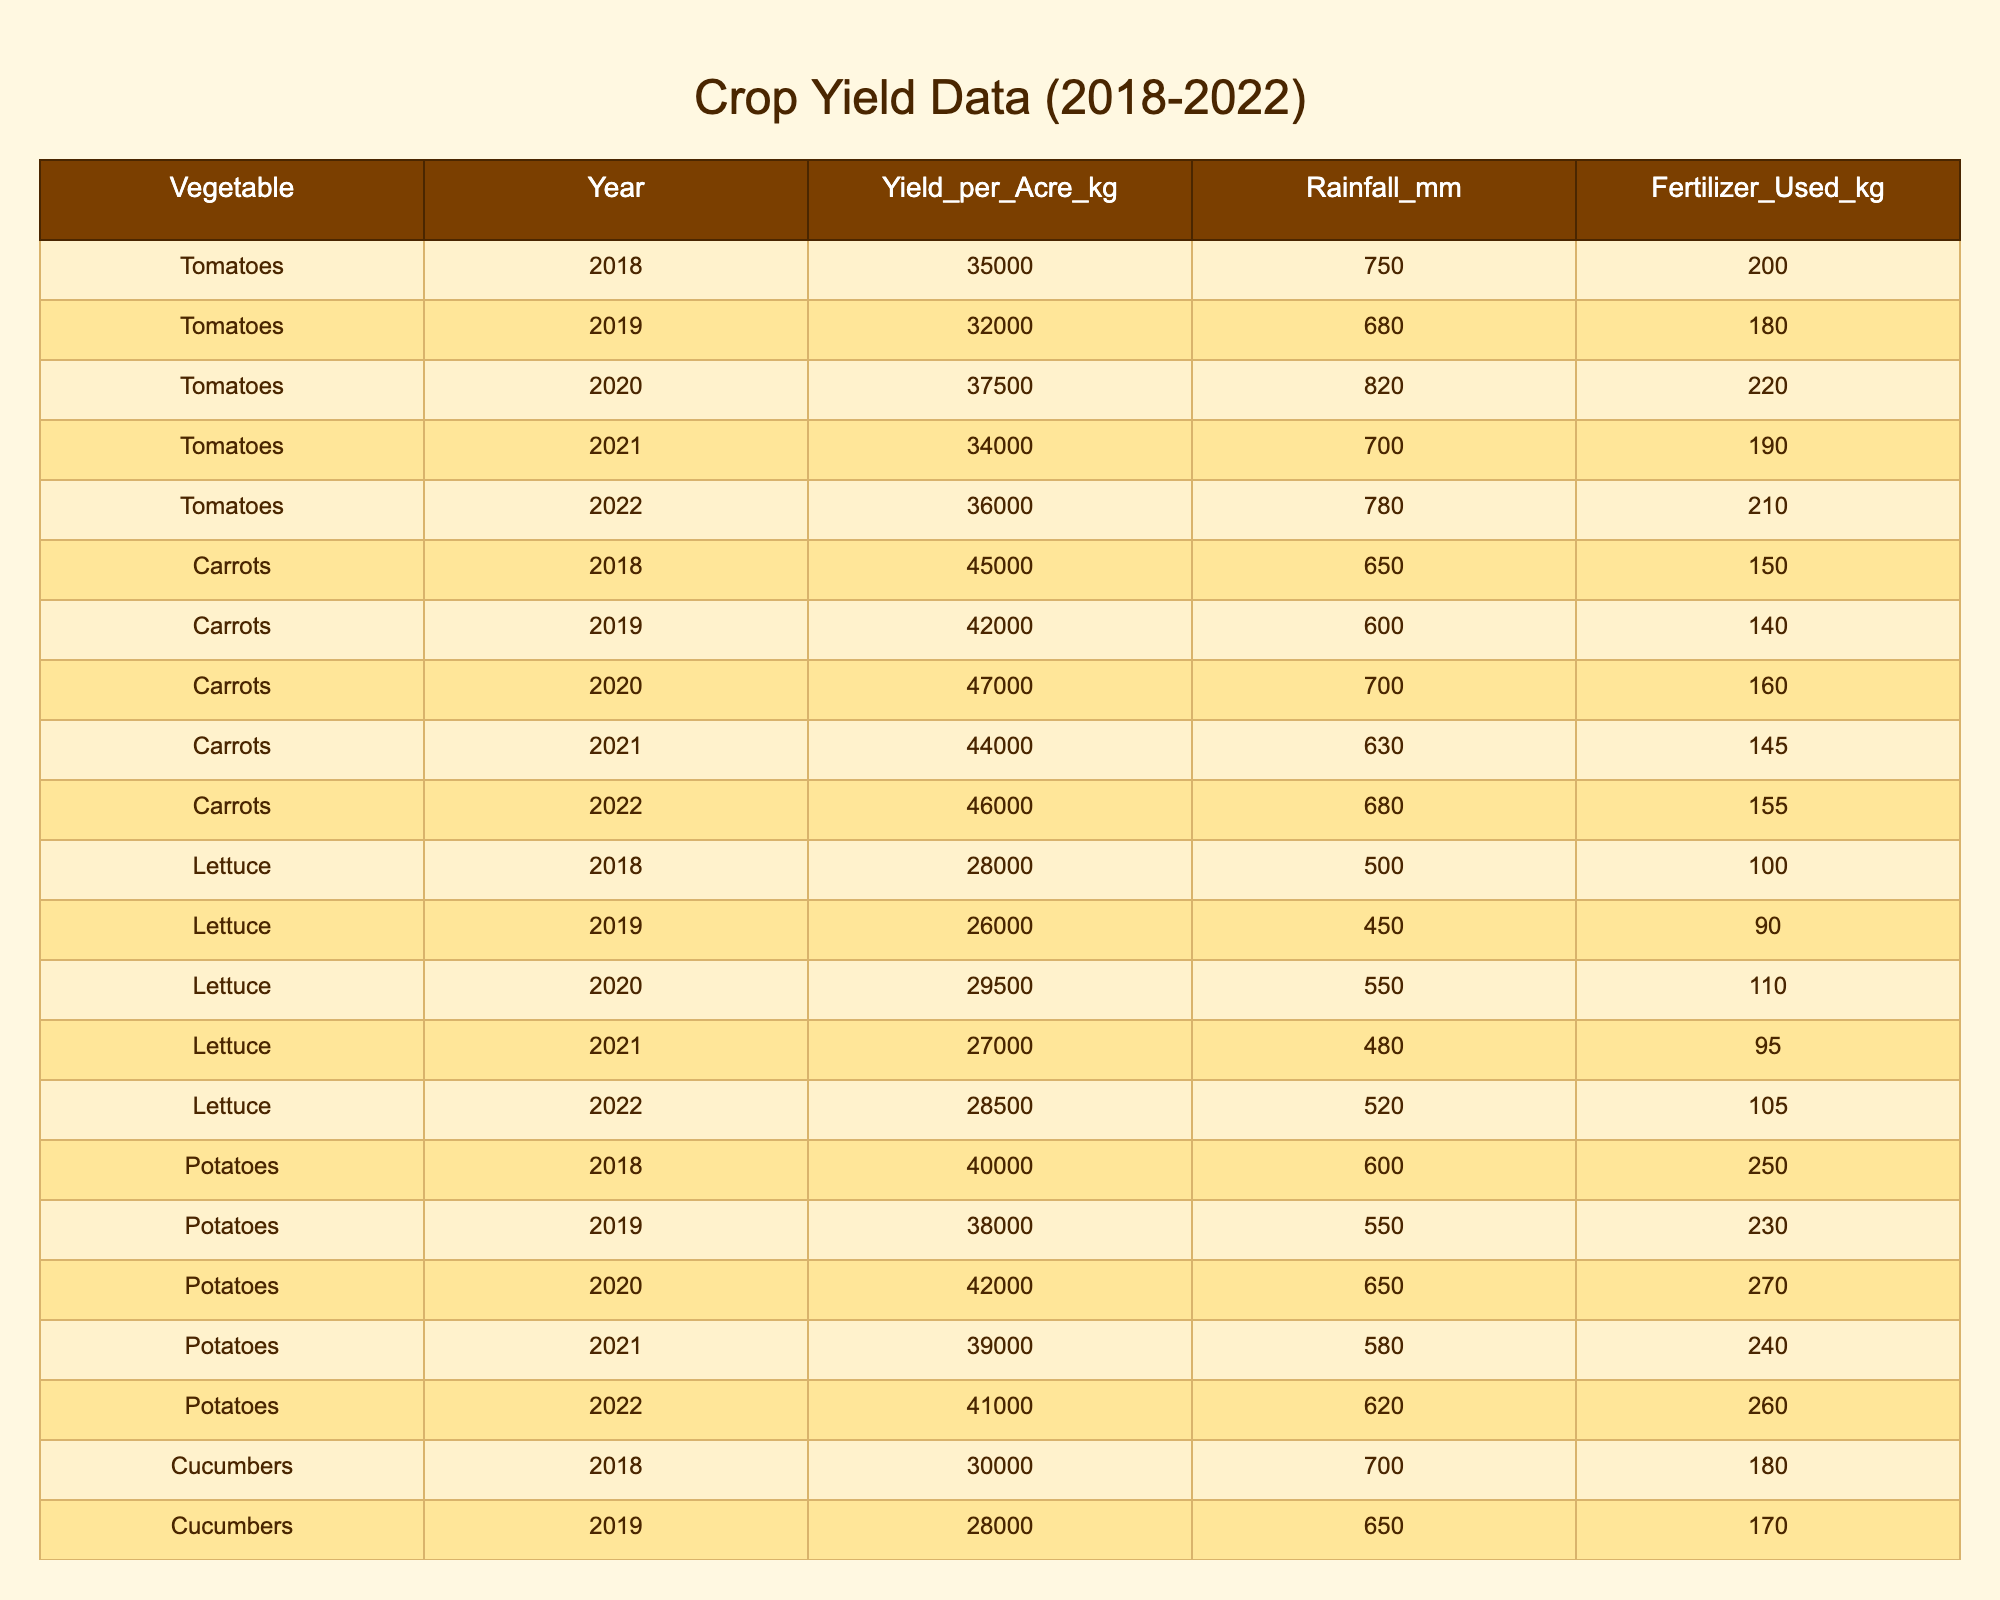What was the yield of carrots in the year 2020? From the table, the yield of carrots for the year 2020 is noted in the "Yield_per_Acre_kg" column aligned with the row for carrots and the year 2020. The value is 47000 kg.
Answer: 47000 kg Which vegetable had the highest yield in 2021? By comparing the yields of all vegetables for the year 2021, I see that tomatoes had a yield of 34000 kg, carrots had 44000 kg, lettuce had 27000 kg, potatoes had 39000 kg, and cucumbers had 29000 kg. The highest yield is carrots with 44000 kg.
Answer: Carrots What is the average yield of potatoes over the 5 years? To calculate the average yield of potatoes, I sum the yields for each year (40000 + 38000 + 42000 + 39000 + 41000 = 200000 kg) and then divide by the number of years (5). Thus, the average is 200000 / 5 = 40000 kg.
Answer: 40000 kg Did cucumber yields increase every year from 2018 to 2022? Checking the cucumber yields for each year: 2018 was 30000 kg, 2019 was 28000 kg, 2020 was 32000 kg, 2021 was 29000 kg, and 2022 was 31000 kg. Since the yield decreased from 2018 to 2019 and again from 2020 to 2021, the answer is no.
Answer: No What was the total yield for tomatoes from 2018 to 2022? I need to add the yields for tomatoes for each year: 35000 + 32000 + 37500 + 34000 + 36000 = 172500 kg. Hence, the total yield for tomatoes is 172500 kg.
Answer: 172500 kg Which year had the lowest rainfall for carrots? Looking at the rainfall data for carrots, the years are: 2018 (650 mm), 2019 (600 mm), 2020 (700 mm), 2021 (630 mm), and 2022 (680 mm). The lowest recorded rainfall is in the year 2019 with 600 mm.
Answer: 2019 What percentage increase in yield did tomatoes see from 2019 to 2020? To find the percentage increase, I first find the difference in yield: 37500 - 32000 = 5500 kg. Then, I divide the difference by the original yield (32000) and multiply by 100: (5500 / 32000) * 100 = 17.19%. Thus, the percentage increase is approximately 17.19%.
Answer: 17.19% Can we say that higher fertilizer usage consistently leads to higher yields for all crops in this data? By reviewing the data, while some crops like potatoes have higher yield with increased fertilizer, other crops like cucumbers show no consistent relationship as they have lower yields in some years despite higher fertilizer usage. Thus, the statement is false.
Answer: No What is the median yield per acre for lettuce over the years? The yields for lettuce are 28000, 26000, 29500, 27000, and 28500. When sorted, they are: 26000, 27000, 28000, 28500, 29500. The median is the middle value, which is 28000 kg.
Answer: 28000 kg How much fertilizer was used on potatoes in 2020? Directly from the table, the fertilizer used for potatoes in 2020 is found in the corresponding row which states 270 kg.
Answer: 270 kg 